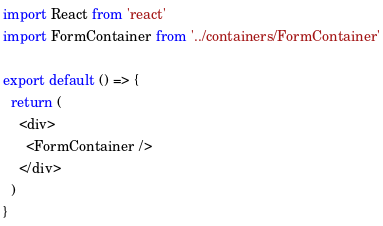Convert code to text. <code><loc_0><loc_0><loc_500><loc_500><_JavaScript_>import React from 'react'
import FormContainer from '../containers/FormContainer'

export default () => {
  return (
    <div>
      <FormContainer />
    </div>
  )
}
</code> 